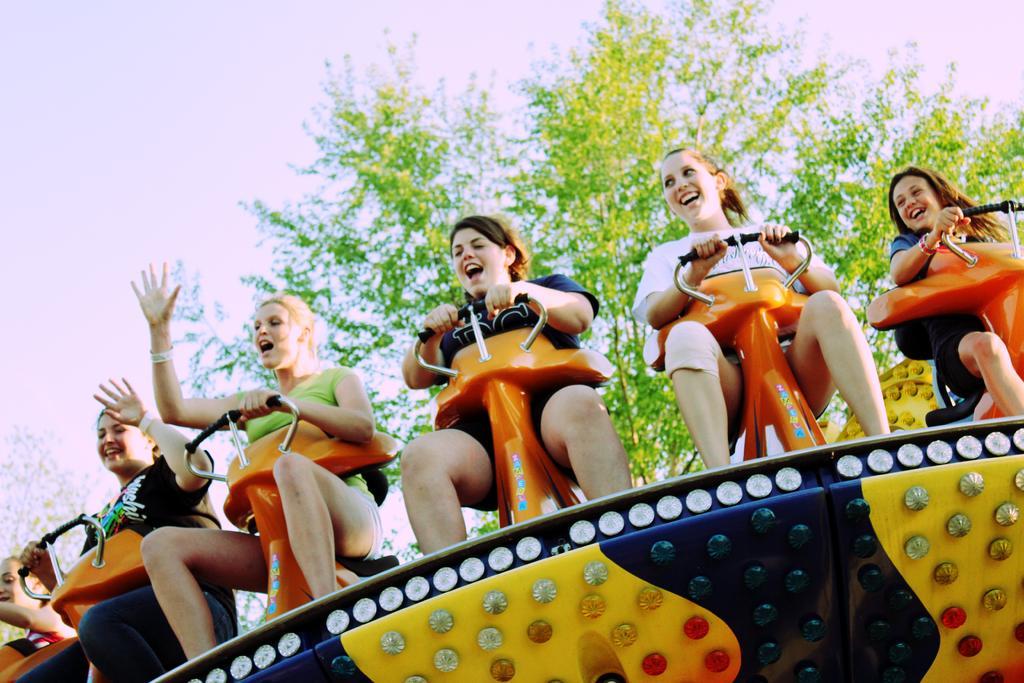Can you describe this image briefly? In this image I can see few women are sitting on a vehicle and enjoying. On the top of the image I can see a tree and the sky. 